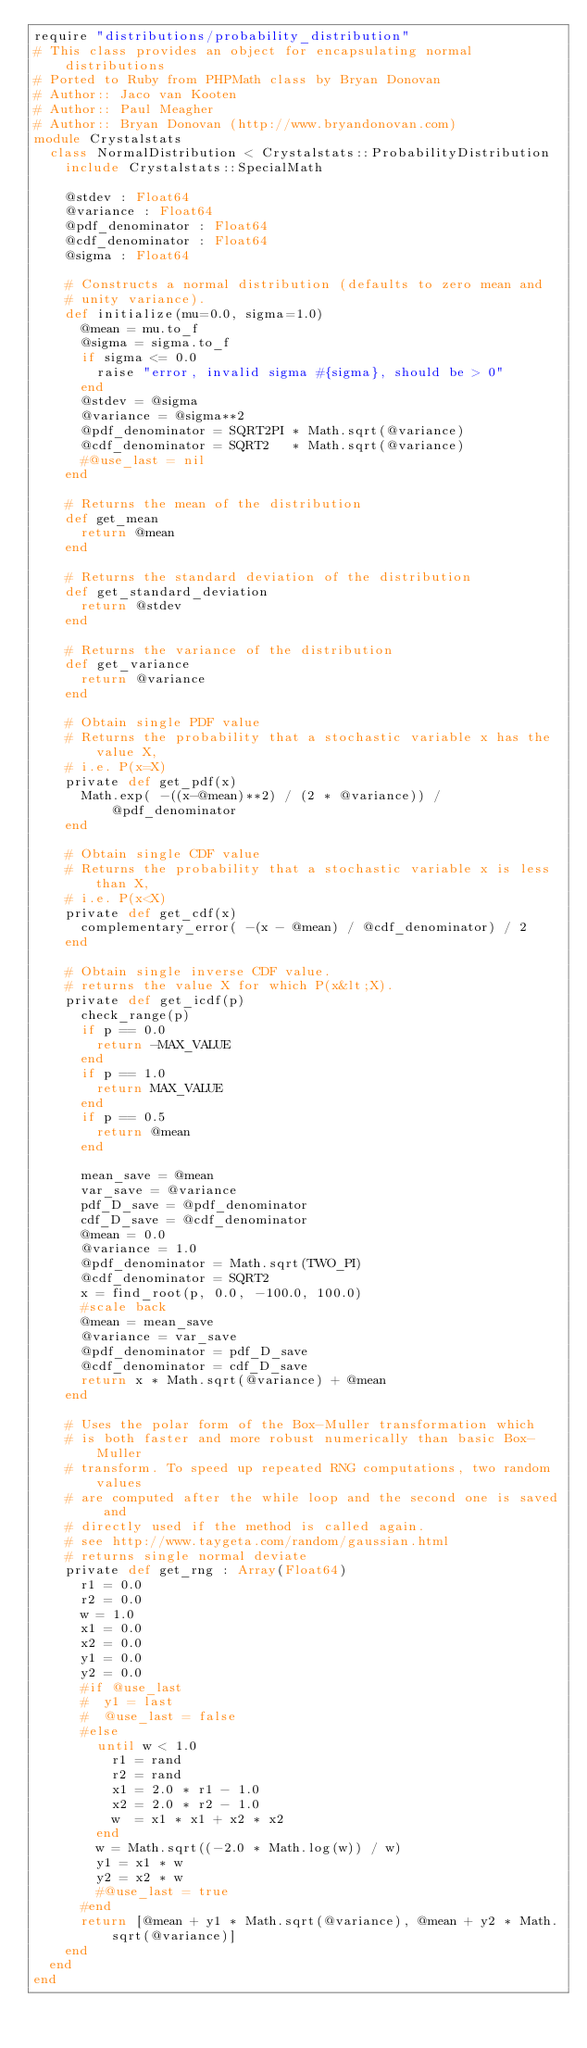Convert code to text. <code><loc_0><loc_0><loc_500><loc_500><_Crystal_>require "distributions/probability_distribution"
# This class provides an object for encapsulating normal distributions
# Ported to Ruby from PHPMath class by Bryan Donovan
# Author:: Jaco van Kooten 
# Author:: Paul Meagher
# Author:: Bryan Donovan (http://www.bryandonovan.com)
module Crystalstats
  class NormalDistribution < Crystalstats::ProbabilityDistribution
    include Crystalstats::SpecialMath

    @stdev : Float64
    @variance : Float64
    @pdf_denominator : Float64
    @cdf_denominator : Float64
    @sigma : Float64

    # Constructs a normal distribution (defaults to zero mean and
    # unity variance).
    def initialize(mu=0.0, sigma=1.0)
      @mean = mu.to_f
      @sigma = sigma.to_f
      if sigma <= 0.0
        raise "error, invalid sigma #{sigma}, should be > 0"
      end
      @stdev = @sigma
      @variance = @sigma**2
      @pdf_denominator = SQRT2PI * Math.sqrt(@variance)
      @cdf_denominator = SQRT2   * Math.sqrt(@variance)
      #@use_last = nil
    end

    # Returns the mean of the distribution
    def get_mean 
      return @mean
    end

    # Returns the standard deviation of the distribution
    def get_standard_deviation
      return @stdev
    end

    # Returns the variance of the distribution
    def get_variance
      return @variance
    end

    # Obtain single PDF value
    # Returns the probability that a stochastic variable x has the value X,
    # i.e. P(x=X)
    private def get_pdf(x)
      Math.exp( -((x-@mean)**2) / (2 * @variance)) / @pdf_denominator
    end

    # Obtain single CDF value
    # Returns the probability that a stochastic variable x is less than X,
    # i.e. P(x<X)
    private def get_cdf(x)
      complementary_error( -(x - @mean) / @cdf_denominator) / 2
    end

    # Obtain single inverse CDF value.
    #	returns the value X for which P(x&lt;X).
    private def get_icdf(p)
      check_range(p)
      if p == 0.0
        return -MAX_VALUE
      end
      if p == 1.0
        return MAX_VALUE
      end
      if p == 0.5
        return @mean
      end

      mean_save = @mean
      var_save = @variance
      pdf_D_save = @pdf_denominator
      cdf_D_save = @cdf_denominator
      @mean = 0.0
      @variance = 1.0
      @pdf_denominator = Math.sqrt(TWO_PI)
      @cdf_denominator = SQRT2
      x = find_root(p, 0.0, -100.0, 100.0)
      #scale back
      @mean = mean_save
      @variance = var_save
      @pdf_denominator = pdf_D_save
      @cdf_denominator = cdf_D_save
      return x * Math.sqrt(@variance) + @mean
    end

    # Uses the polar form of the Box-Muller transformation which
    #	is both faster and more robust numerically than basic Box-Muller
    # transform. To speed up repeated RNG computations, two random values
    # are computed after the while loop and the second one is saved and
    # directly used if the method is called again.
    # see http://www.taygeta.com/random/gaussian.html
    # returns single normal deviate
    private def get_rng : Array(Float64)
      r1 = 0.0
      r2 = 0.0
      w = 1.0
      x1 = 0.0
      x2 = 0.0
      y1 = 0.0
      y2 = 0.0
      #if @use_last
      #  y1 = last
      #  @use_last = false
      #else
        until w < 1.0
          r1 = rand
          r2 = rand
          x1 = 2.0 * r1 - 1.0
          x2 = 2.0 * r2 - 1.0
          w  = x1 * x1 + x2 * x2
        end
        w = Math.sqrt((-2.0 * Math.log(w)) / w)
        y1 = x1 * w
        y2 = x2 * w
        #@use_last = true
      #end
      return [@mean + y1 * Math.sqrt(@variance), @mean + y2 * Math.sqrt(@variance)]
    end
  end
end
</code> 